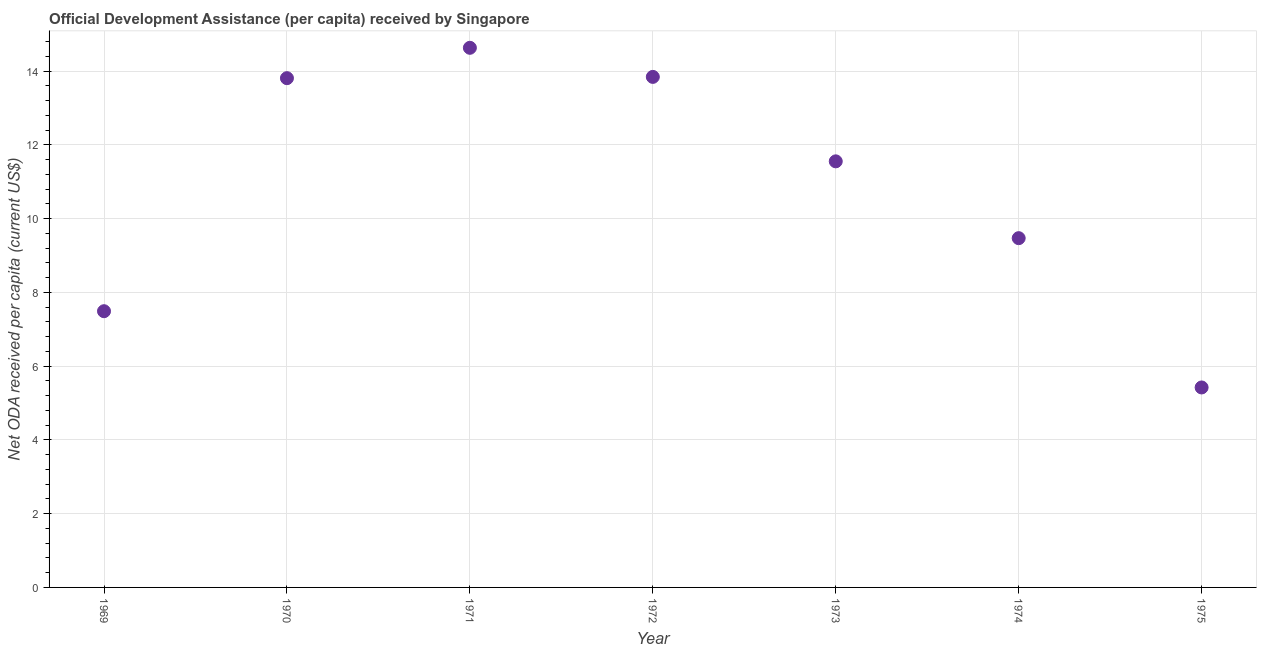What is the net oda received per capita in 1975?
Ensure brevity in your answer.  5.42. Across all years, what is the maximum net oda received per capita?
Make the answer very short. 14.63. Across all years, what is the minimum net oda received per capita?
Give a very brief answer. 5.42. In which year was the net oda received per capita maximum?
Provide a short and direct response. 1971. In which year was the net oda received per capita minimum?
Keep it short and to the point. 1975. What is the sum of the net oda received per capita?
Give a very brief answer. 76.23. What is the difference between the net oda received per capita in 1970 and 1973?
Your answer should be very brief. 2.26. What is the average net oda received per capita per year?
Make the answer very short. 10.89. What is the median net oda received per capita?
Your answer should be very brief. 11.55. What is the ratio of the net oda received per capita in 1970 to that in 1971?
Your answer should be very brief. 0.94. What is the difference between the highest and the second highest net oda received per capita?
Provide a short and direct response. 0.79. Is the sum of the net oda received per capita in 1969 and 1970 greater than the maximum net oda received per capita across all years?
Offer a very short reply. Yes. What is the difference between the highest and the lowest net oda received per capita?
Give a very brief answer. 9.21. In how many years, is the net oda received per capita greater than the average net oda received per capita taken over all years?
Keep it short and to the point. 4. Does the net oda received per capita monotonically increase over the years?
Ensure brevity in your answer.  No. How many dotlines are there?
Provide a succinct answer. 1. What is the difference between two consecutive major ticks on the Y-axis?
Your answer should be compact. 2. Are the values on the major ticks of Y-axis written in scientific E-notation?
Offer a very short reply. No. Does the graph contain grids?
Make the answer very short. Yes. What is the title of the graph?
Provide a succinct answer. Official Development Assistance (per capita) received by Singapore. What is the label or title of the Y-axis?
Your answer should be compact. Net ODA received per capita (current US$). What is the Net ODA received per capita (current US$) in 1969?
Ensure brevity in your answer.  7.49. What is the Net ODA received per capita (current US$) in 1970?
Give a very brief answer. 13.81. What is the Net ODA received per capita (current US$) in 1971?
Ensure brevity in your answer.  14.63. What is the Net ODA received per capita (current US$) in 1972?
Provide a succinct answer. 13.85. What is the Net ODA received per capita (current US$) in 1973?
Your answer should be compact. 11.55. What is the Net ODA received per capita (current US$) in 1974?
Provide a succinct answer. 9.47. What is the Net ODA received per capita (current US$) in 1975?
Provide a succinct answer. 5.42. What is the difference between the Net ODA received per capita (current US$) in 1969 and 1970?
Offer a very short reply. -6.32. What is the difference between the Net ODA received per capita (current US$) in 1969 and 1971?
Make the answer very short. -7.14. What is the difference between the Net ODA received per capita (current US$) in 1969 and 1972?
Make the answer very short. -6.35. What is the difference between the Net ODA received per capita (current US$) in 1969 and 1973?
Your answer should be very brief. -4.06. What is the difference between the Net ODA received per capita (current US$) in 1969 and 1974?
Give a very brief answer. -1.98. What is the difference between the Net ODA received per capita (current US$) in 1969 and 1975?
Offer a terse response. 2.07. What is the difference between the Net ODA received per capita (current US$) in 1970 and 1971?
Provide a succinct answer. -0.82. What is the difference between the Net ODA received per capita (current US$) in 1970 and 1972?
Your answer should be very brief. -0.03. What is the difference between the Net ODA received per capita (current US$) in 1970 and 1973?
Give a very brief answer. 2.26. What is the difference between the Net ODA received per capita (current US$) in 1970 and 1974?
Provide a short and direct response. 4.34. What is the difference between the Net ODA received per capita (current US$) in 1970 and 1975?
Give a very brief answer. 8.39. What is the difference between the Net ODA received per capita (current US$) in 1971 and 1972?
Provide a succinct answer. 0.79. What is the difference between the Net ODA received per capita (current US$) in 1971 and 1973?
Your answer should be very brief. 3.08. What is the difference between the Net ODA received per capita (current US$) in 1971 and 1974?
Keep it short and to the point. 5.16. What is the difference between the Net ODA received per capita (current US$) in 1971 and 1975?
Give a very brief answer. 9.21. What is the difference between the Net ODA received per capita (current US$) in 1972 and 1973?
Your answer should be very brief. 2.29. What is the difference between the Net ODA received per capita (current US$) in 1972 and 1974?
Offer a very short reply. 4.37. What is the difference between the Net ODA received per capita (current US$) in 1972 and 1975?
Give a very brief answer. 8.42. What is the difference between the Net ODA received per capita (current US$) in 1973 and 1974?
Your answer should be very brief. 2.08. What is the difference between the Net ODA received per capita (current US$) in 1973 and 1975?
Provide a short and direct response. 6.13. What is the difference between the Net ODA received per capita (current US$) in 1974 and 1975?
Offer a terse response. 4.05. What is the ratio of the Net ODA received per capita (current US$) in 1969 to that in 1970?
Give a very brief answer. 0.54. What is the ratio of the Net ODA received per capita (current US$) in 1969 to that in 1971?
Offer a terse response. 0.51. What is the ratio of the Net ODA received per capita (current US$) in 1969 to that in 1972?
Offer a very short reply. 0.54. What is the ratio of the Net ODA received per capita (current US$) in 1969 to that in 1973?
Keep it short and to the point. 0.65. What is the ratio of the Net ODA received per capita (current US$) in 1969 to that in 1974?
Ensure brevity in your answer.  0.79. What is the ratio of the Net ODA received per capita (current US$) in 1969 to that in 1975?
Your answer should be compact. 1.38. What is the ratio of the Net ODA received per capita (current US$) in 1970 to that in 1971?
Your answer should be very brief. 0.94. What is the ratio of the Net ODA received per capita (current US$) in 1970 to that in 1972?
Provide a succinct answer. 1. What is the ratio of the Net ODA received per capita (current US$) in 1970 to that in 1973?
Provide a succinct answer. 1.2. What is the ratio of the Net ODA received per capita (current US$) in 1970 to that in 1974?
Provide a short and direct response. 1.46. What is the ratio of the Net ODA received per capita (current US$) in 1970 to that in 1975?
Provide a succinct answer. 2.55. What is the ratio of the Net ODA received per capita (current US$) in 1971 to that in 1972?
Your response must be concise. 1.06. What is the ratio of the Net ODA received per capita (current US$) in 1971 to that in 1973?
Provide a succinct answer. 1.27. What is the ratio of the Net ODA received per capita (current US$) in 1971 to that in 1974?
Your answer should be compact. 1.54. What is the ratio of the Net ODA received per capita (current US$) in 1971 to that in 1975?
Provide a succinct answer. 2.7. What is the ratio of the Net ODA received per capita (current US$) in 1972 to that in 1973?
Provide a short and direct response. 1.2. What is the ratio of the Net ODA received per capita (current US$) in 1972 to that in 1974?
Your answer should be compact. 1.46. What is the ratio of the Net ODA received per capita (current US$) in 1972 to that in 1975?
Provide a succinct answer. 2.55. What is the ratio of the Net ODA received per capita (current US$) in 1973 to that in 1974?
Ensure brevity in your answer.  1.22. What is the ratio of the Net ODA received per capita (current US$) in 1973 to that in 1975?
Give a very brief answer. 2.13. What is the ratio of the Net ODA received per capita (current US$) in 1974 to that in 1975?
Keep it short and to the point. 1.75. 